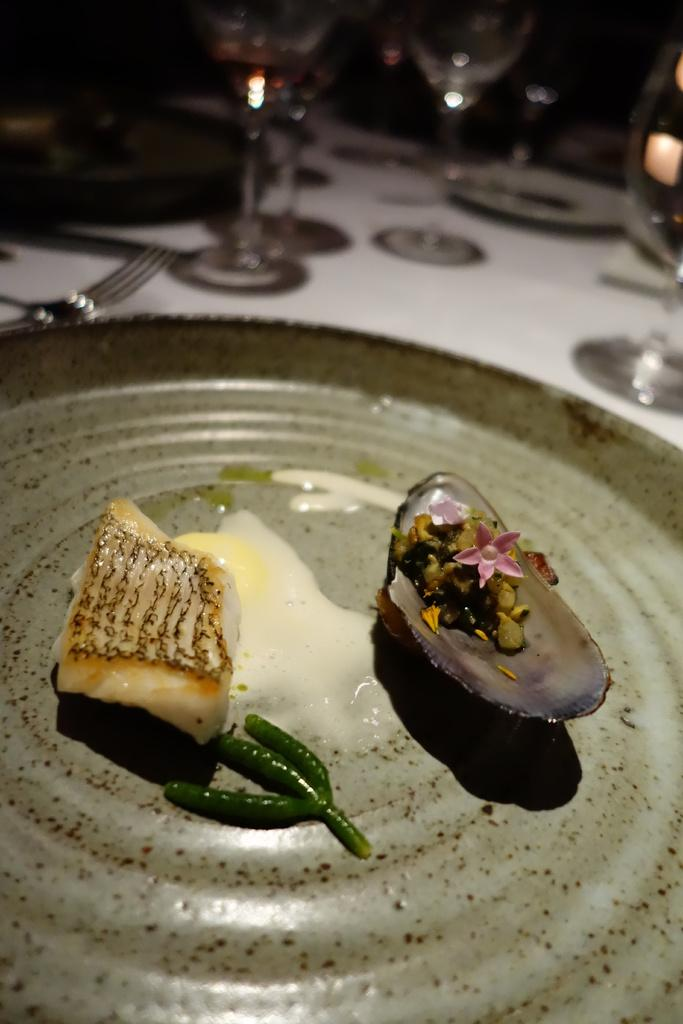What is on the plate in the image? There is food on a plate in the image. What else can be seen in the background of the image? There are glasses in the background of the image. What utensil is present in the image? There is a fork in the image. What type of wine is being served in the image? There is no wine present in the image; it only shows food on a plate, glasses in the background, and a fork. 